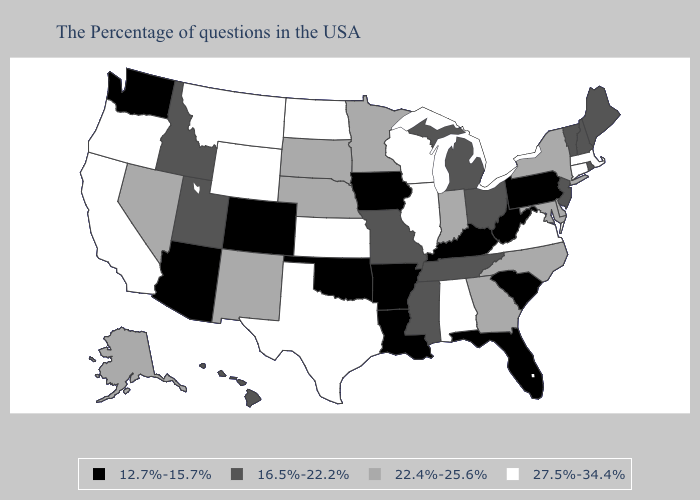What is the value of Michigan?
Quick response, please. 16.5%-22.2%. Does Rhode Island have the lowest value in the USA?
Be succinct. No. Among the states that border Oklahoma , does Texas have the lowest value?
Be succinct. No. What is the lowest value in states that border North Carolina?
Answer briefly. 12.7%-15.7%. Does Montana have the highest value in the West?
Short answer required. Yes. What is the lowest value in the West?
Quick response, please. 12.7%-15.7%. Which states have the highest value in the USA?
Quick response, please. Massachusetts, Connecticut, Virginia, Alabama, Wisconsin, Illinois, Kansas, Texas, North Dakota, Wyoming, Montana, California, Oregon. What is the value of Ohio?
Answer briefly. 16.5%-22.2%. What is the value of Maryland?
Be succinct. 22.4%-25.6%. What is the lowest value in states that border Idaho?
Answer briefly. 12.7%-15.7%. What is the value of Kentucky?
Answer briefly. 12.7%-15.7%. Among the states that border North Dakota , which have the lowest value?
Short answer required. Minnesota, South Dakota. Name the states that have a value in the range 27.5%-34.4%?
Be succinct. Massachusetts, Connecticut, Virginia, Alabama, Wisconsin, Illinois, Kansas, Texas, North Dakota, Wyoming, Montana, California, Oregon. What is the highest value in the USA?
Be succinct. 27.5%-34.4%. Which states have the lowest value in the USA?
Give a very brief answer. Pennsylvania, South Carolina, West Virginia, Florida, Kentucky, Louisiana, Arkansas, Iowa, Oklahoma, Colorado, Arizona, Washington. 